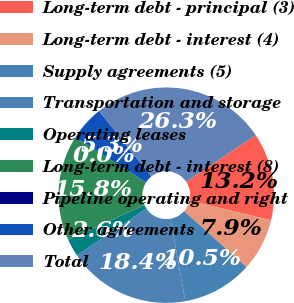Convert chart. <chart><loc_0><loc_0><loc_500><loc_500><pie_chart><fcel>Long-term debt - principal (3)<fcel>Long-term debt - interest (4)<fcel>Supply agreements (5)<fcel>Transportation and storage<fcel>Operating leases<fcel>Long-term debt - interest (8)<fcel>Pipeline operating and right<fcel>Other agreements<fcel>Total<nl><fcel>13.16%<fcel>7.9%<fcel>10.53%<fcel>18.42%<fcel>2.64%<fcel>15.79%<fcel>0.01%<fcel>5.27%<fcel>26.3%<nl></chart> 